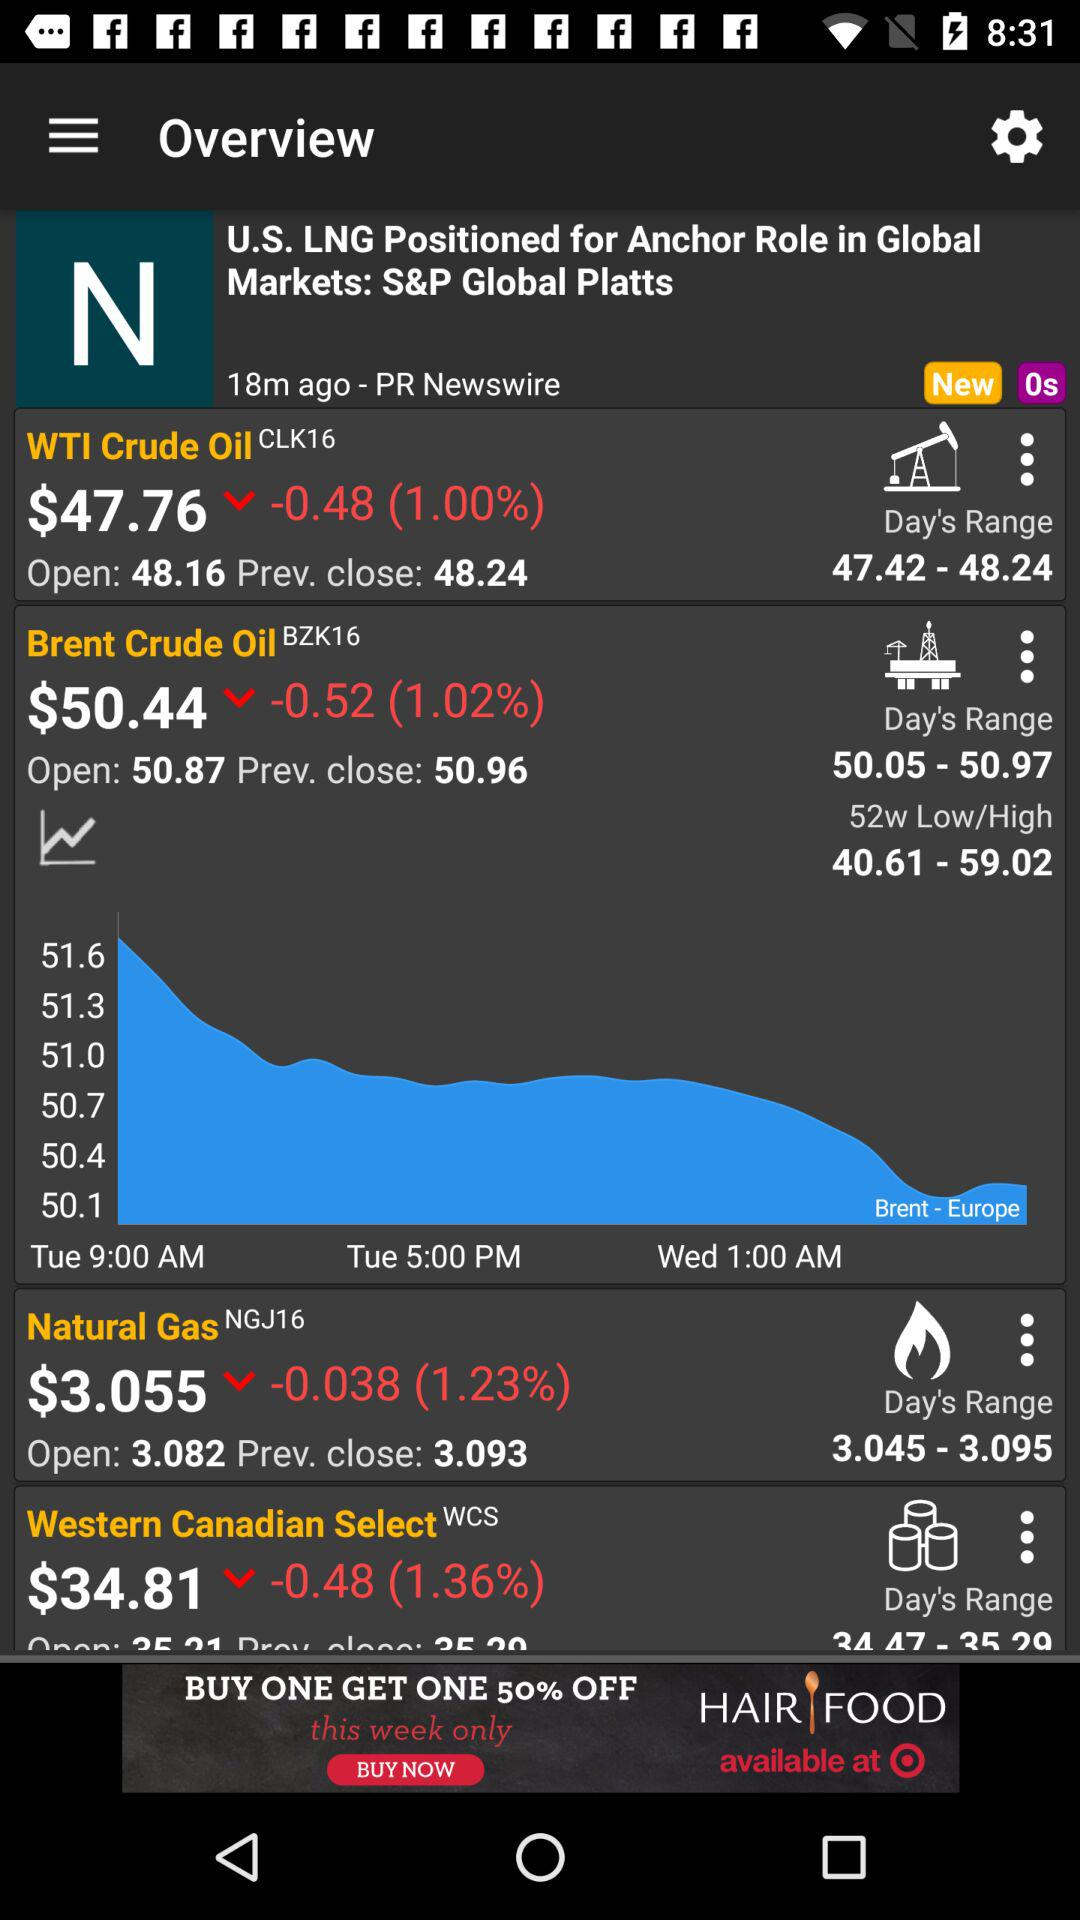What is the price of the "WTI Crude Oil" share? The price is $47.76. 